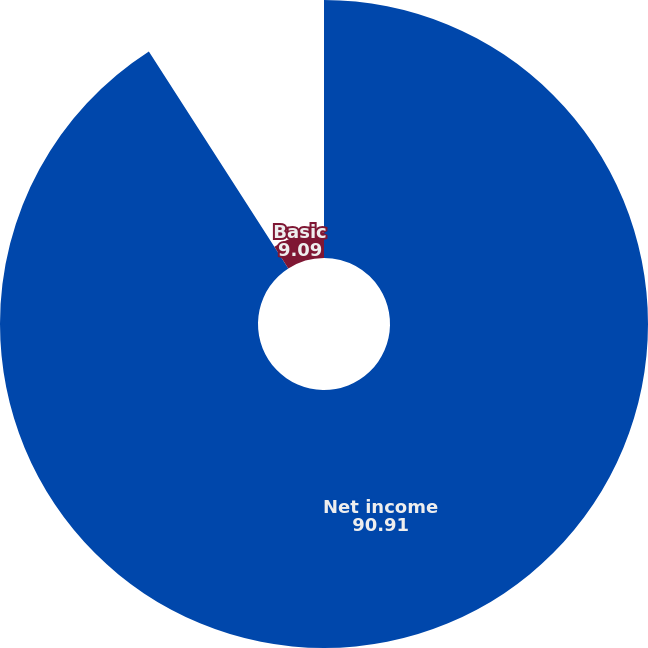Convert chart. <chart><loc_0><loc_0><loc_500><loc_500><pie_chart><fcel>Net income<fcel>Basic<fcel>Diluted<nl><fcel>90.91%<fcel>9.09%<fcel>0.0%<nl></chart> 